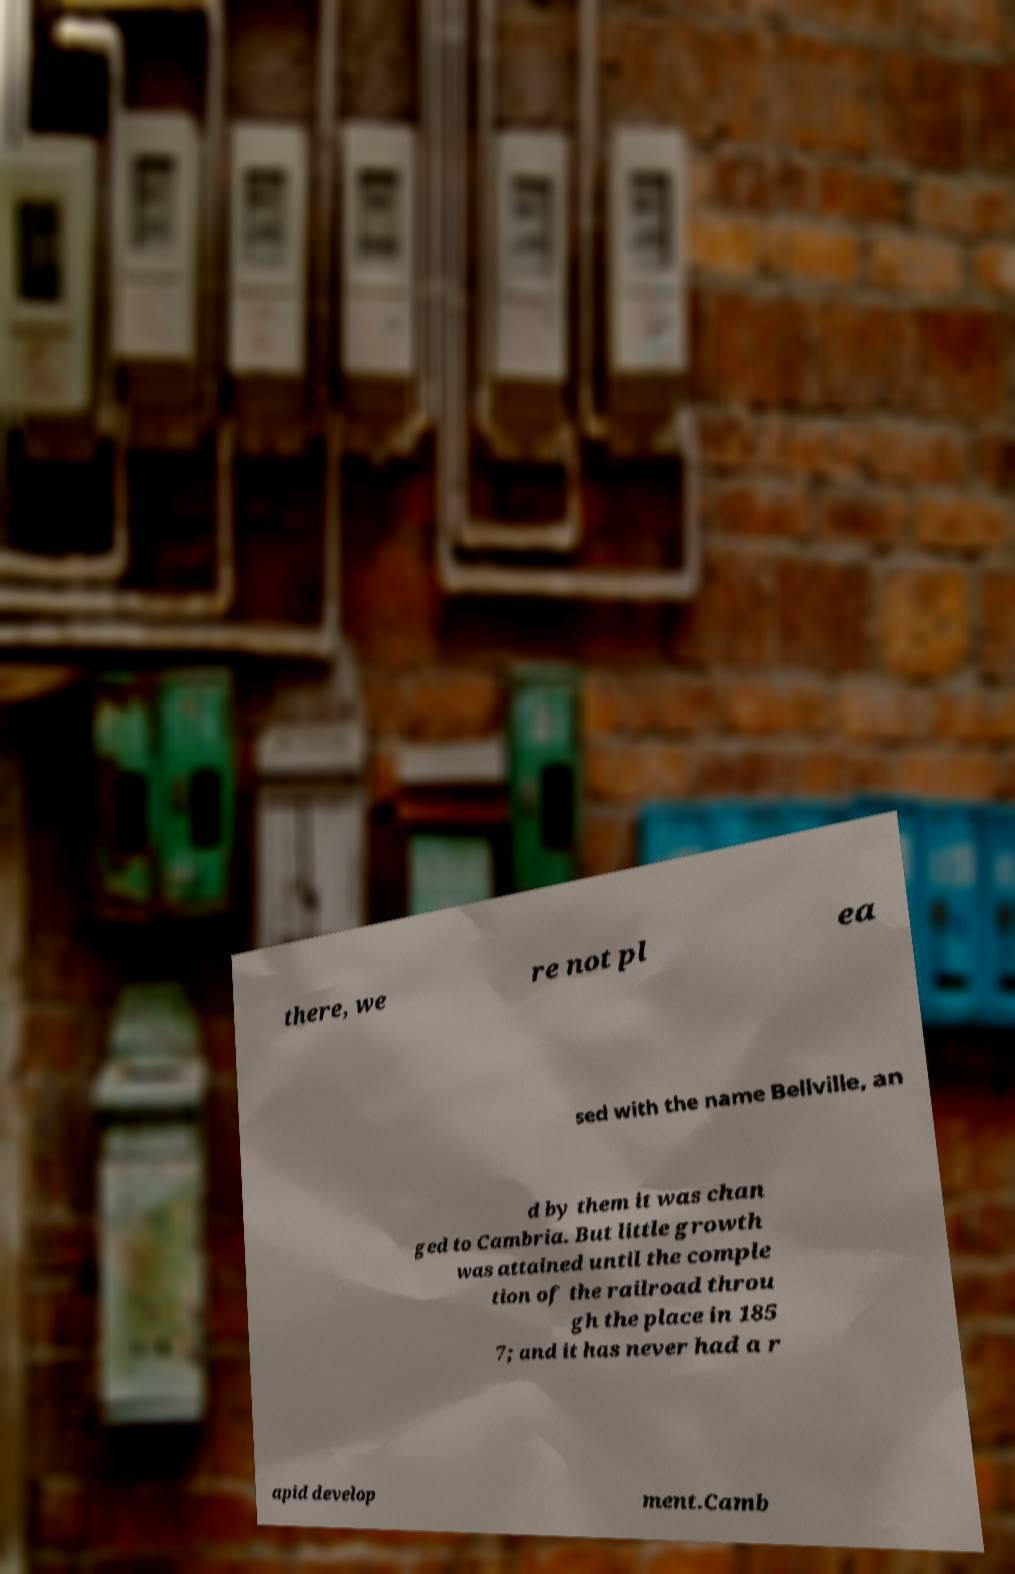There's text embedded in this image that I need extracted. Can you transcribe it verbatim? there, we re not pl ea sed with the name Bellville, an d by them it was chan ged to Cambria. But little growth was attained until the comple tion of the railroad throu gh the place in 185 7; and it has never had a r apid develop ment.Camb 